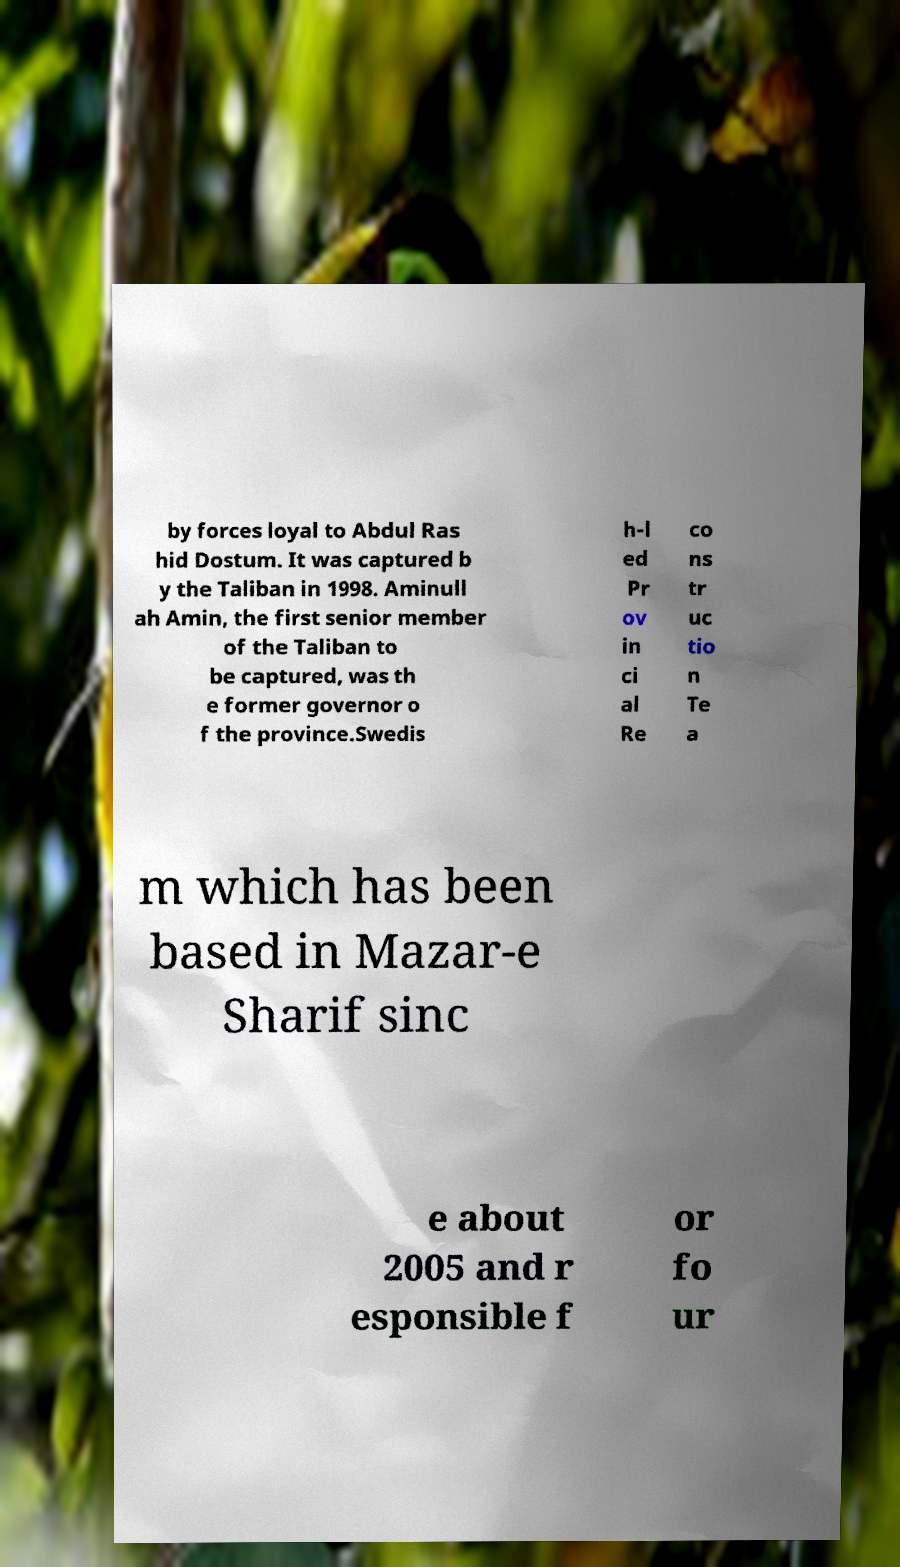Could you assist in decoding the text presented in this image and type it out clearly? by forces loyal to Abdul Ras hid Dostum. It was captured b y the Taliban in 1998. Aminull ah Amin, the first senior member of the Taliban to be captured, was th e former governor o f the province.Swedis h-l ed Pr ov in ci al Re co ns tr uc tio n Te a m which has been based in Mazar-e Sharif sinc e about 2005 and r esponsible f or fo ur 